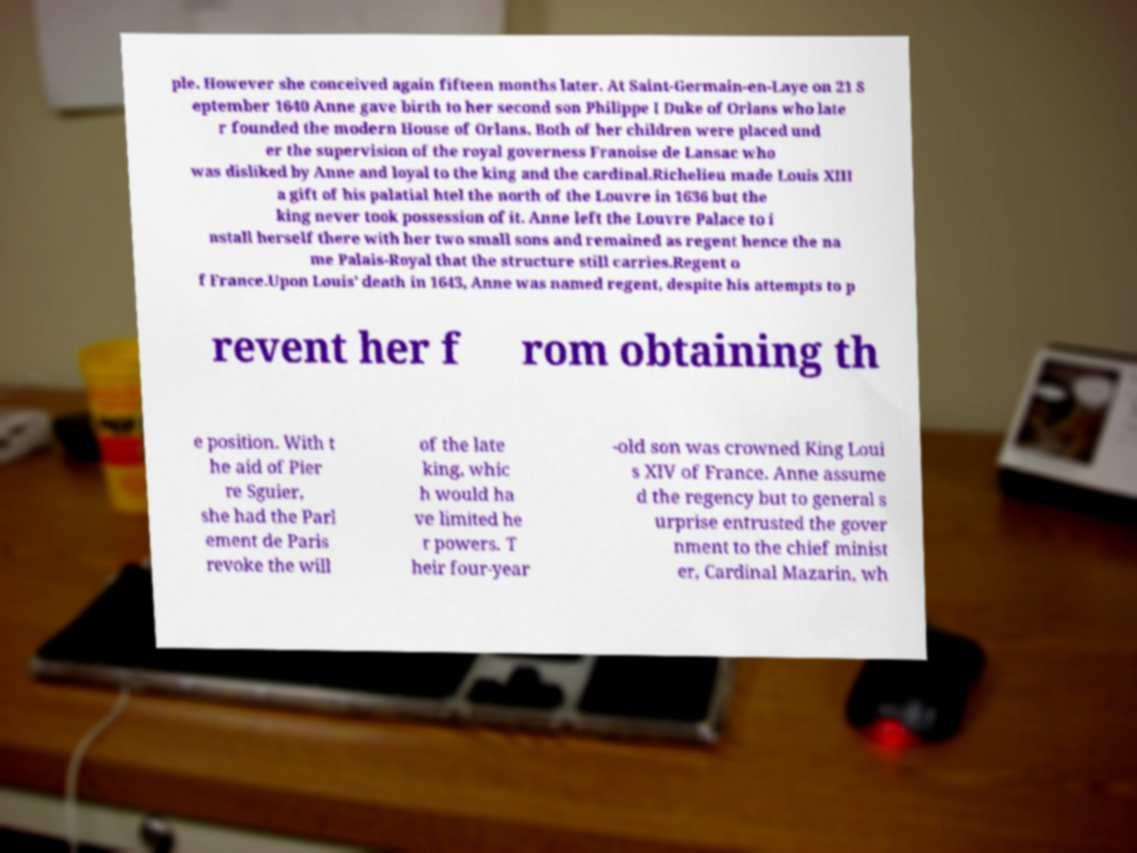Could you assist in decoding the text presented in this image and type it out clearly? ple. However she conceived again fifteen months later. At Saint-Germain-en-Laye on 21 S eptember 1640 Anne gave birth to her second son Philippe I Duke of Orlans who late r founded the modern House of Orlans. Both of her children were placed und er the supervision of the royal governess Franoise de Lansac who was disliked by Anne and loyal to the king and the cardinal.Richelieu made Louis XIII a gift of his palatial htel the north of the Louvre in 1636 but the king never took possession of it. Anne left the Louvre Palace to i nstall herself there with her two small sons and remained as regent hence the na me Palais-Royal that the structure still carries.Regent o f France.Upon Louis’ death in 1643, Anne was named regent, despite his attempts to p revent her f rom obtaining th e position. With t he aid of Pier re Sguier, she had the Parl ement de Paris revoke the will of the late king, whic h would ha ve limited he r powers. T heir four-year -old son was crowned King Loui s XIV of France. Anne assume d the regency but to general s urprise entrusted the gover nment to the chief minist er, Cardinal Mazarin, wh 